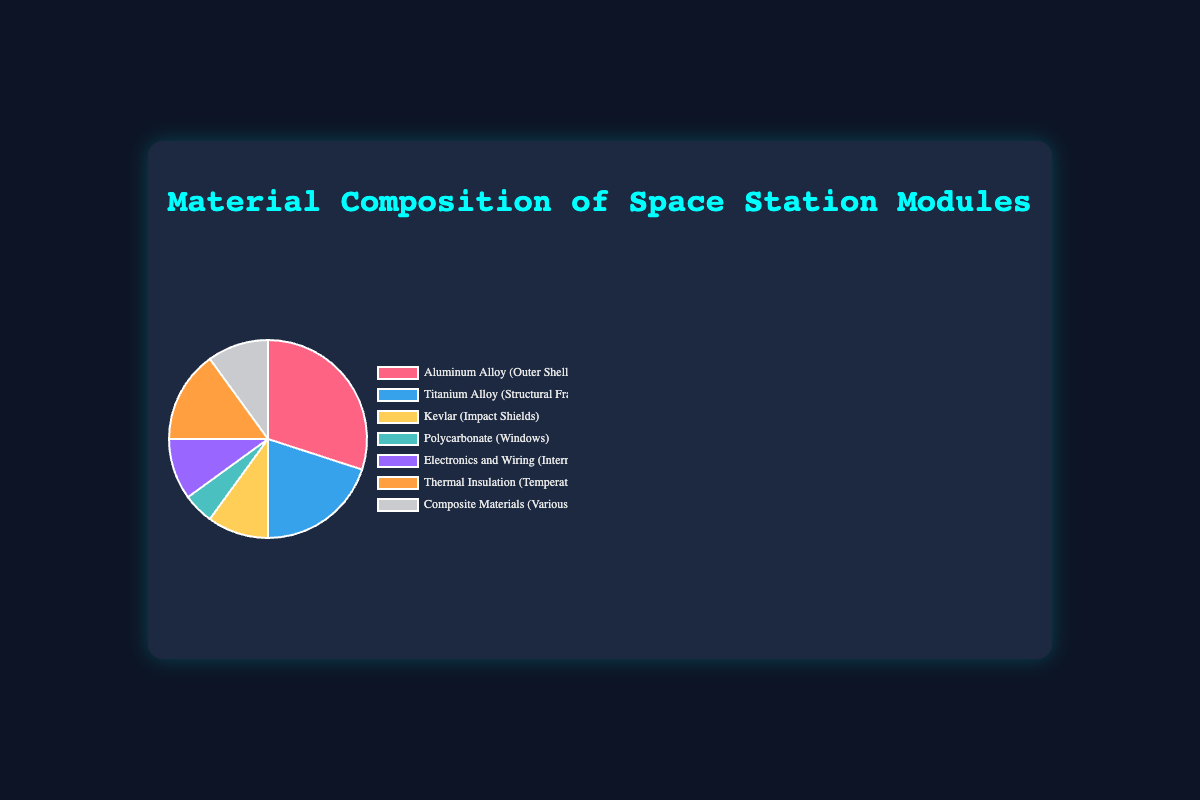What is the material used for the Outer Shell and its percentage? The material used for the Outer Shell can be identified by looking at the label and percentage value in the pie chart. The label for the Outer Shell is “Aluminum Alloy” and its percentage is 30%.
Answer: Aluminum Alloy, 30% Which material contributes the least to the composition of Space Station Modules? The pie chart shows segments of varying sizes. The smallest segment corresponds to the Windows, which is made from Polycarbonate at 5%.
Answer: Polycarbonate, 5% How much greater is the percentage of Aluminum Alloy compared to Polycarbonate? The percentage of Aluminum Alloy is 30% and Polycarbonate is 5%. The difference is 30 - 5 = 25%.
Answer: 25% What are the visual characteristics of the segment representing the Impact Shields? The segment representing Kevlar (Impact Shields) should be identified by its color. In the pie chart, Kevlar is represented by the yellow segment.
Answer: Yellow segment Calculate the total percentage of all materials used for internal systems and temperature control. The materials are Electronics and Wiring (10%) and Thermal Insulation (15%). Adding these values gives 10 + 15 = 25%.
Answer: 25% Which material has a percentage equal to that of Composite Materials? Both Composite Materials and Kevlar (Impact Shields) have a percentage of 10%.
Answer: Kevlar, 10% How does the percentage of Titanium Alloy compare to that of Composite Materials? Titanium Alloy has a percentage of 20%, while Composite Materials have 10%. Therefore, Titanium Alloy is greater.
Answer: Titanium Alloy is greater What is the combined percentage of all structural materials (Aluminum Alloy and Titanium Alloy)? Aluminum Alloy is 30% and Titanium Alloy is 20%. The combined percentage is 30 + 20 = 50%.
Answer: 50% Which component is represented by an orange segment, and what is its percentage? Looking at the pie chart, Thermal Insulation (Temperature Control) is represented by the orange segment with a percentage of 15%.
Answer: Thermal Insulation, 15% If we combine the percentages of the two smallest segments, what is the total? The two smallest segments are Polycarbonate (Windows) at 5% and Electronics and Wiring (Internal Systems) at 10%. The total is 5 + 10 = 15%.
Answer: 15% 